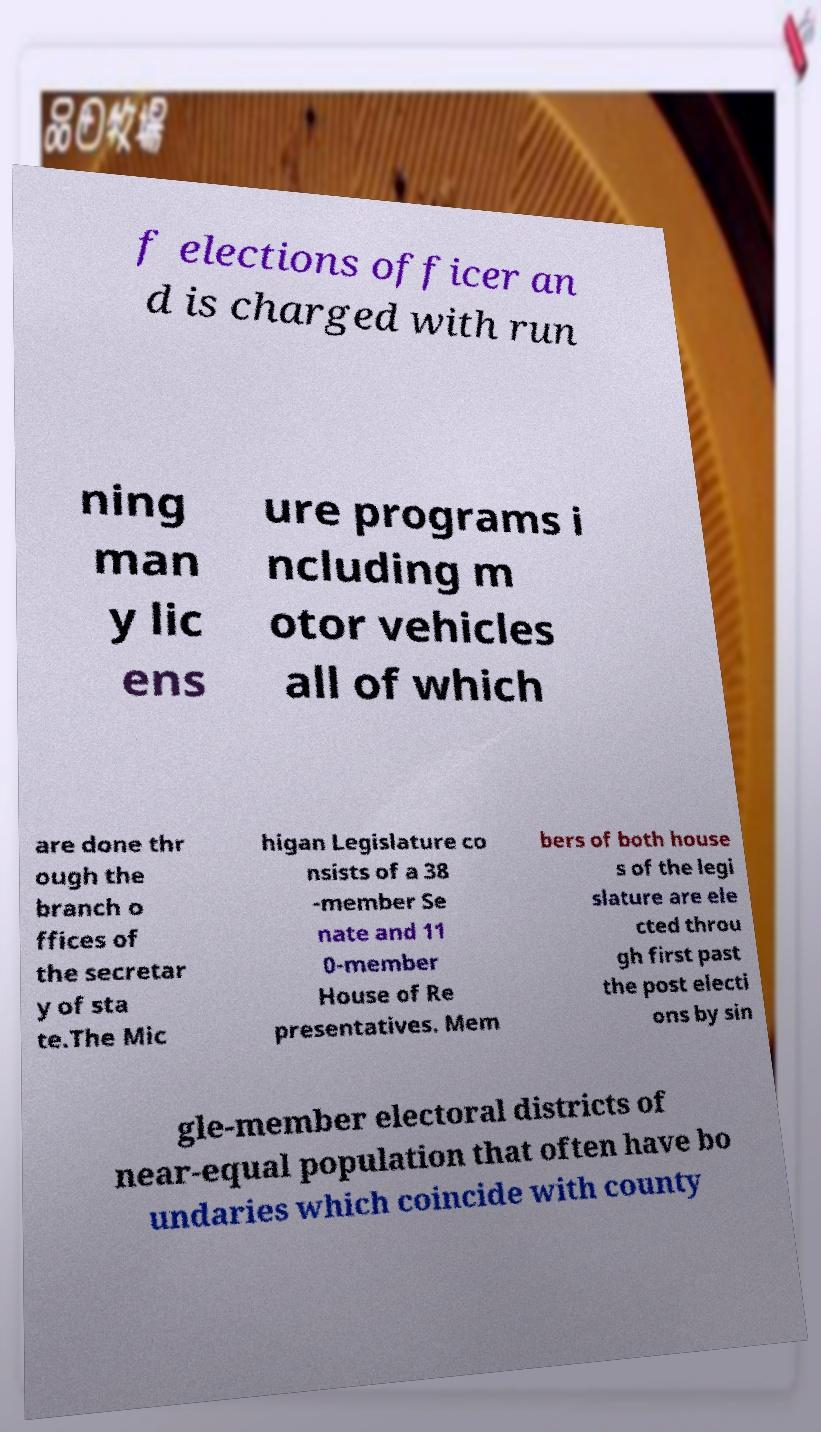Can you accurately transcribe the text from the provided image for me? f elections officer an d is charged with run ning man y lic ens ure programs i ncluding m otor vehicles all of which are done thr ough the branch o ffices of the secretar y of sta te.The Mic higan Legislature co nsists of a 38 -member Se nate and 11 0-member House of Re presentatives. Mem bers of both house s of the legi slature are ele cted throu gh first past the post electi ons by sin gle-member electoral districts of near-equal population that often have bo undaries which coincide with county 